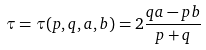Convert formula to latex. <formula><loc_0><loc_0><loc_500><loc_500>\tau = \tau ( p , q , a , b ) = 2 \frac { q a - p b } { p + q }</formula> 